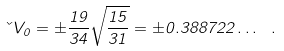Convert formula to latex. <formula><loc_0><loc_0><loc_500><loc_500>\kappa V _ { 0 } = \pm \frac { 1 9 } { 3 4 } \sqrt { \frac { 1 5 } { 3 1 } } = \pm 0 . 3 8 8 7 2 2 \dots \ .</formula> 